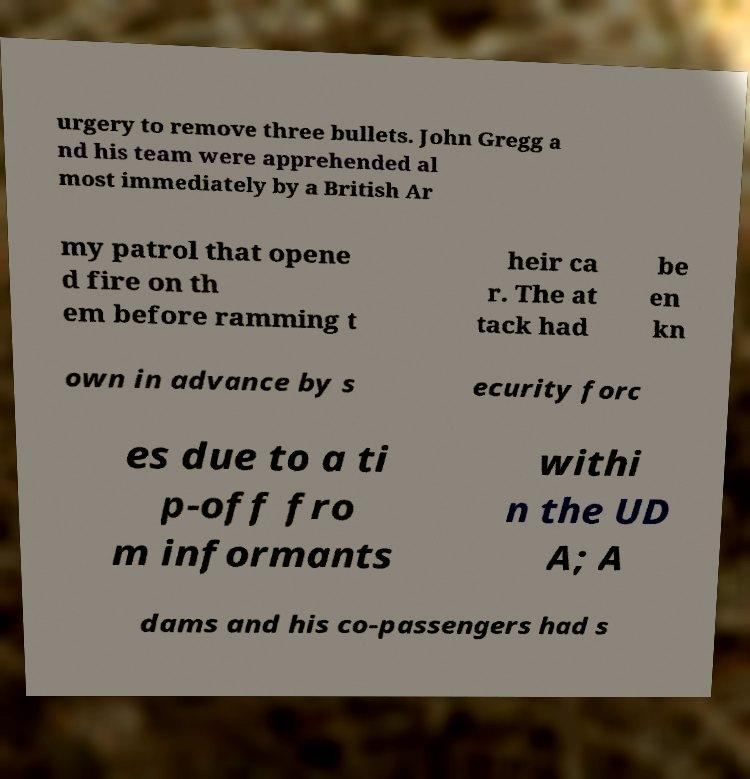For documentation purposes, I need the text within this image transcribed. Could you provide that? urgery to remove three bullets. John Gregg a nd his team were apprehended al most immediately by a British Ar my patrol that opene d fire on th em before ramming t heir ca r. The at tack had be en kn own in advance by s ecurity forc es due to a ti p-off fro m informants withi n the UD A; A dams and his co-passengers had s 